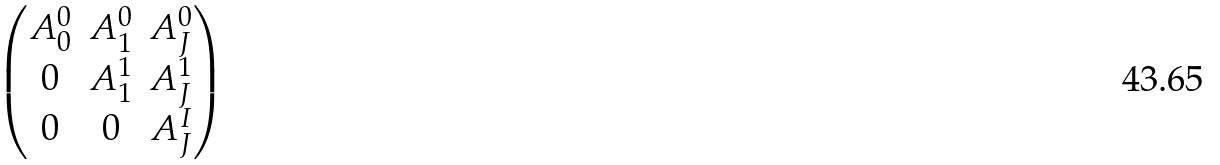Convert formula to latex. <formula><loc_0><loc_0><loc_500><loc_500>\begin{pmatrix} A ^ { 0 } _ { 0 } & A ^ { 0 } _ { 1 } & A ^ { 0 } _ { J } \\ 0 & A ^ { 1 } _ { 1 } & A ^ { 1 } _ { J } \\ 0 & 0 & A ^ { I } _ { J } \end{pmatrix}</formula> 